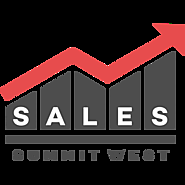Write a detailed description of this image, do not forget about the texts on it if they exist. Also, do not forget to mention the type / style of the image. The image depicts a dynamic graphic design primarily intended for branding or event promotion, focusing on the theme of sales growth. The central feature is the word 'SALES' displayed in large, bold uppercase letters, topped with a stylized bar graph. This graph consists of four vertical bars that progressively increase in height from left to right, culminating in a striking red arrow pointing upwards, symbolizing increasing sales or success. Below this graph, smaller texts, 'SUMMIT' followed by 'WEST', suggest this artwork may be linked to a specific business event or conference with a geographical emphasis on the Western region. The use of a plain white background enhances the visibility and impact of the black and red graphic elements, making it straightforward yet compelling. 